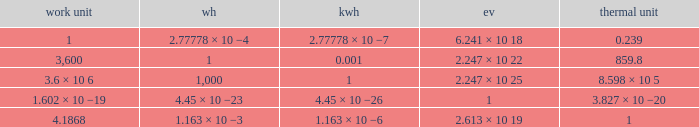How many electronvolts is 3,600 joules? 2.247 × 10 22. 